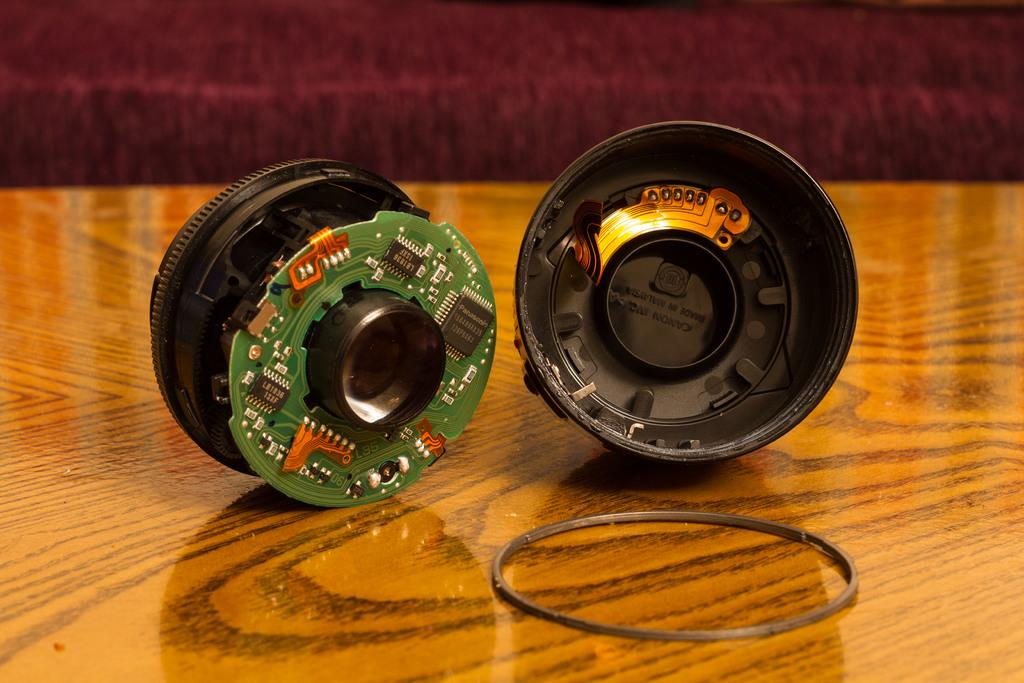What type of object is the main subject of the image? There is an electronic equipment in the image. What component can be seen within the electronic equipment? There is a circuit board in the image. What type of material is used to hold something together in the image? There is a rubber band in the image. What is the surface that the electronic equipment is placed on? There is a wooden surface at the bottom of the image. What type of juice is being poured from a container in the image? There is no container or juice present in the image. What type of brush is being used to clean the library in the image? There is no library or brush present in the image. 